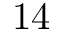Convert formula to latex. <formula><loc_0><loc_0><loc_500><loc_500>1 4</formula> 